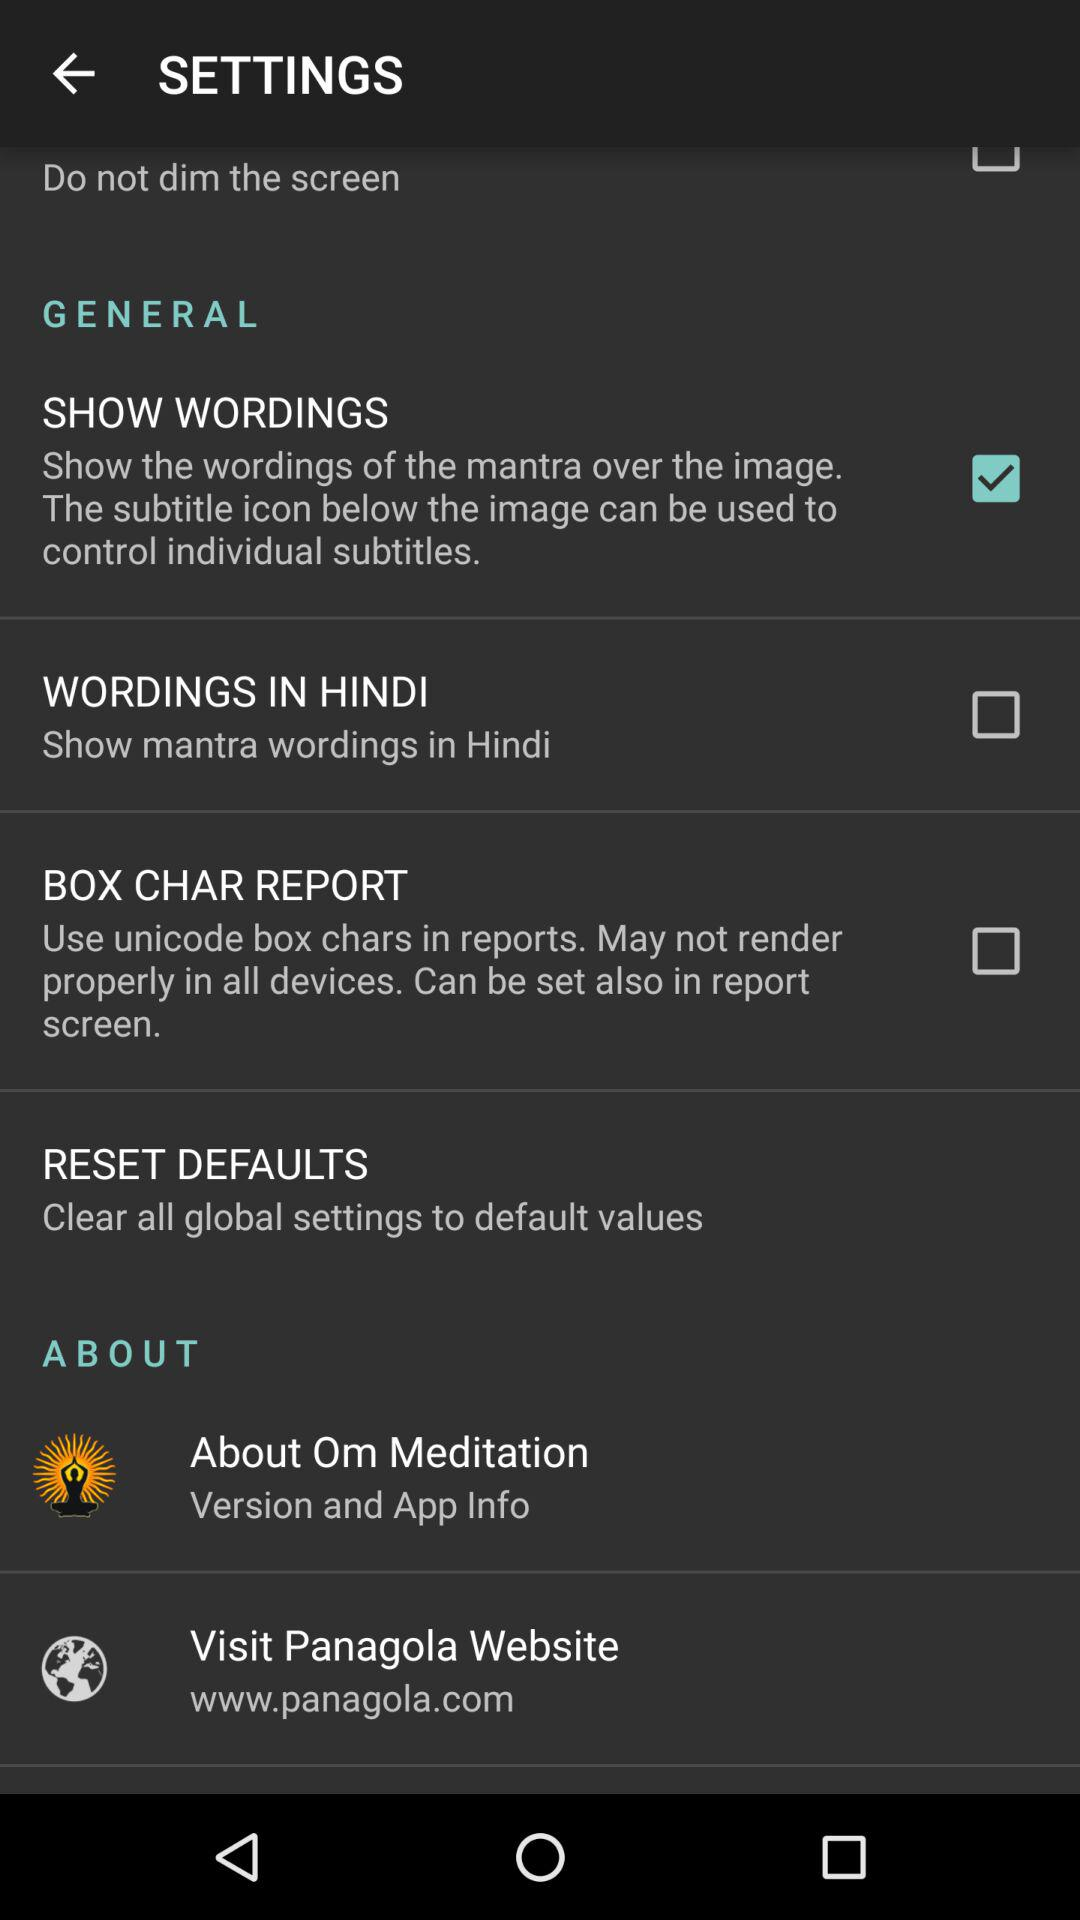How many checkbox options are there in the SETTINGS screen?
Answer the question using a single word or phrase. 4 